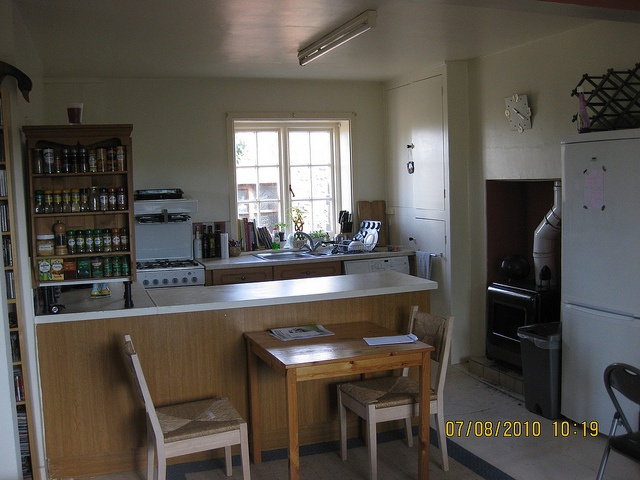Describe the objects in this image and their specific colors. I can see refrigerator in black, gray, and darkblue tones, dining table in black, maroon, and gray tones, chair in black and gray tones, bottle in black, gray, and darkgreen tones, and chair in black and gray tones in this image. 